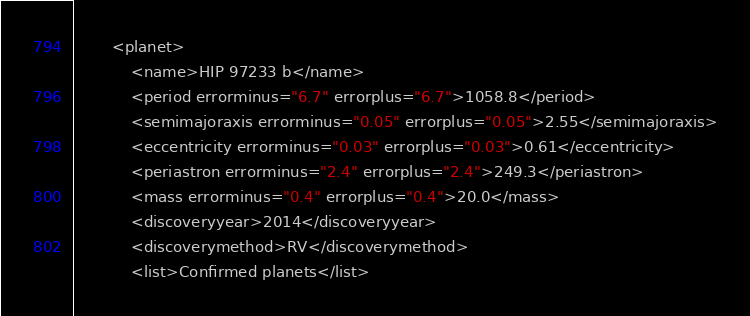Convert code to text. <code><loc_0><loc_0><loc_500><loc_500><_XML_>		<planet>
			<name>HIP 97233 b</name>
			<period errorminus="6.7" errorplus="6.7">1058.8</period>
			<semimajoraxis errorminus="0.05" errorplus="0.05">2.55</semimajoraxis>
			<eccentricity errorminus="0.03" errorplus="0.03">0.61</eccentricity>
			<periastron errorminus="2.4" errorplus="2.4">249.3</periastron>
			<mass errorminus="0.4" errorplus="0.4">20.0</mass>
			<discoveryyear>2014</discoveryyear>
			<discoverymethod>RV</discoverymethod>
			<list>Confirmed planets</list></code> 